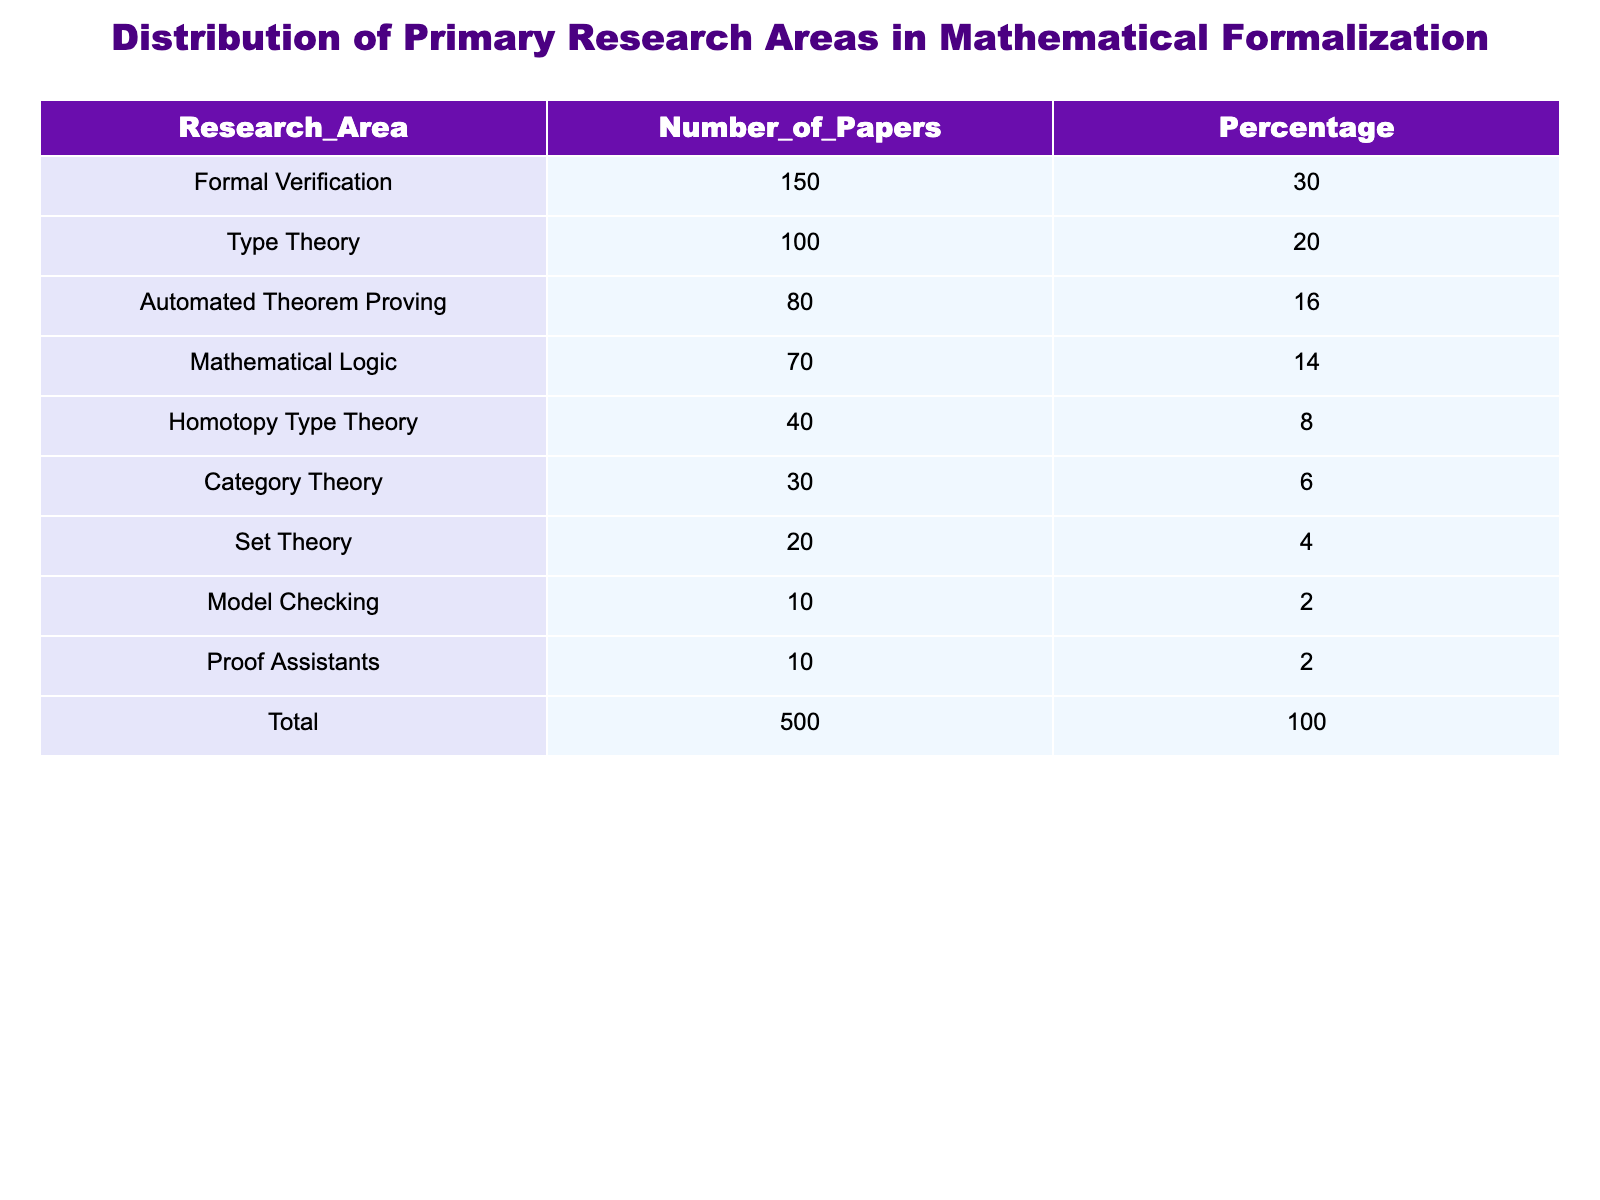What is the number of papers in Formal Verification? According to the table, the "Number_of_Papers" for "Formal Verification" is explicitly listed as 150.
Answer: 150 What percentage of papers focus on Type Theory? The table specifies that "Type Theory" has a "Percentage" of 20%.
Answer: 20% How many more papers are there in Formal Verification compared to Set Theory? The number of papers in "Formal Verification" is 150, while "Set Theory" has 20 papers. The difference is 150 - 20 = 130.
Answer: 130 Is the number of papers in Proof Assistants greater than those in Homotopy Type Theory? The table shows that "Proof Assistants" has 10 papers and "Homotopy Type Theory" has 40 papers. Since 10 is less than 40, the answer is no.
Answer: No What is the combined percentage of papers in Category Theory and Model Checking? From the table, "Category Theory" has 6% and "Model Checking" has 2%. Adding these percentages gives 6 + 2 = 8%.
Answer: 8% What is the average number of papers in the research areas listed, excluding the Total? The sum of the "Number_of_Papers" in the listed areas is 150 + 100 + 80 + 70 + 40 + 30 + 20 + 10 + 10 = 500. There are 9 areas, so the average is 500 / 9 ≈ 55.56.
Answer: Approximately 55.56 What percentage of the total papers are devoted to Automated Theorem Proving and Mathematical Logic? "Automated Theorem Proving" has 16% and "Mathematical Logic" has 14%. Adding these percentages gives 16 + 14 = 30%.
Answer: 30% Which research area has the least number of papers? The table indicates that "Model Checking" and "Proof Assistants," both having 10 papers, are the areas with the least number of papers.
Answer: Model Checking and Proof Assistants How does the percentage of papers in Homotopy Type Theory compare to that in Automated Theorem Proving? "Homotopy Type Theory" has a percentage of 8%, while "Automated Theorem Proving" has 16%. Since 8% is less than 16%, Homotopy Type Theory has a lower percentage.
Answer: Lower 